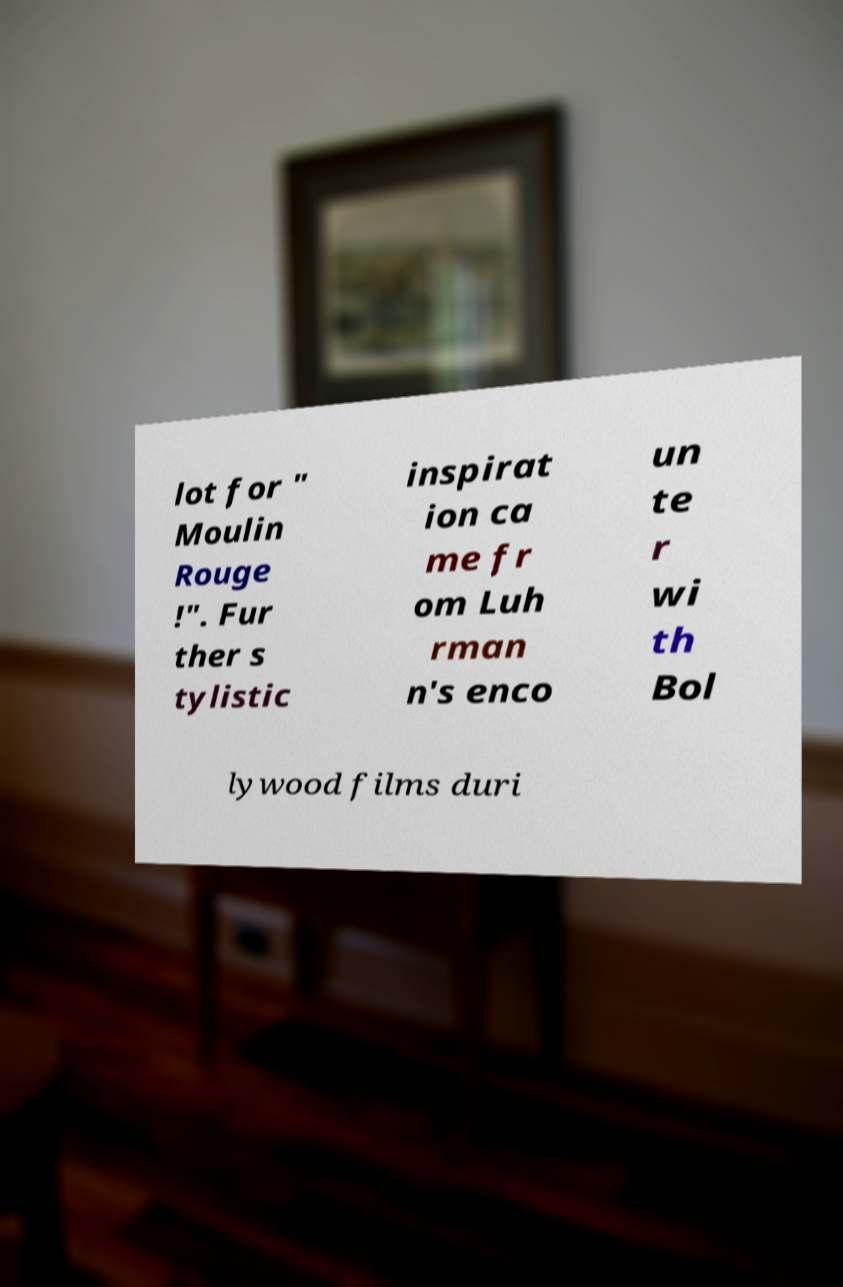I need the written content from this picture converted into text. Can you do that? lot for " Moulin Rouge !". Fur ther s tylistic inspirat ion ca me fr om Luh rman n's enco un te r wi th Bol lywood films duri 